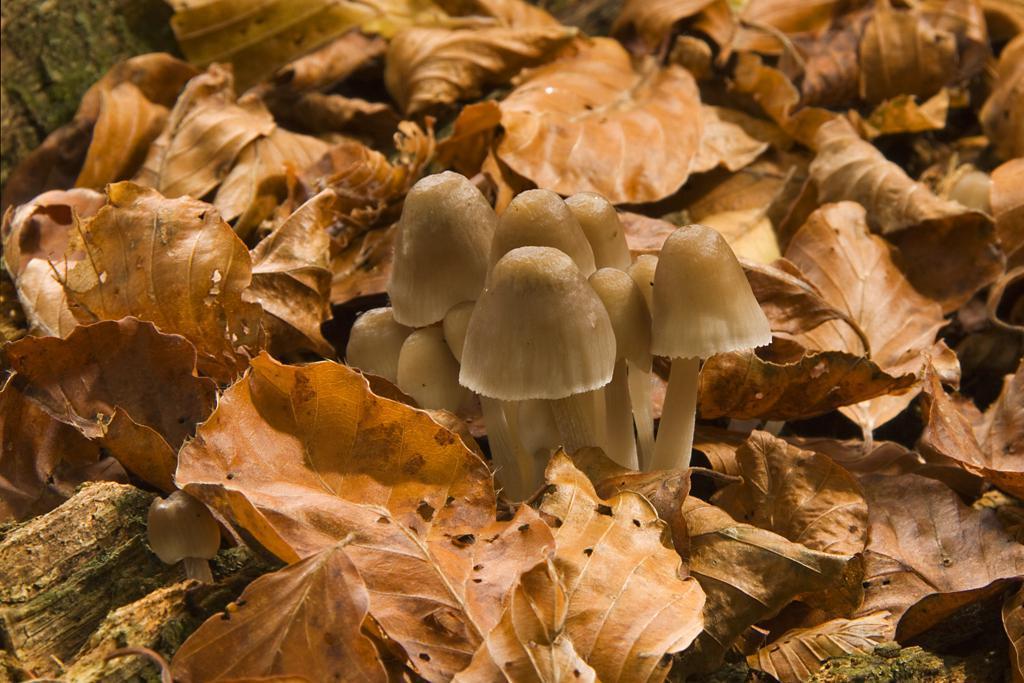Describe this image in one or two sentences. In this image I can see few mushrooms in cream color and I can also see few dried leaves in brown color. 